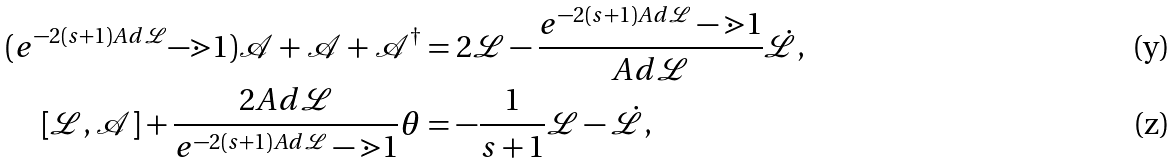<formula> <loc_0><loc_0><loc_500><loc_500>( e ^ { - 2 ( s + 1 ) A d \mathcal { L } } \mathcal { - } \mathbb { m } { 1 } ) \mathcal { A } + \mathcal { A } + \mathcal { A } ^ { \dag } & = 2 \mathcal { L } - \frac { e ^ { - 2 ( s + 1 ) A d \mathcal { L } } - \mathbb { m } { 1 } } { A d \mathcal { L } } \dot { \mathcal { L } } , \\ [ \mathcal { L } , \mathcal { A } ] + \frac { 2 A d \mathcal { L } } { e ^ { - 2 ( s + 1 ) A d \mathcal { L } } - \mathbb { m } { 1 } } \theta & = - \frac { 1 } { s + 1 } \mathcal { L } - \dot { \mathcal { L } } ,</formula> 